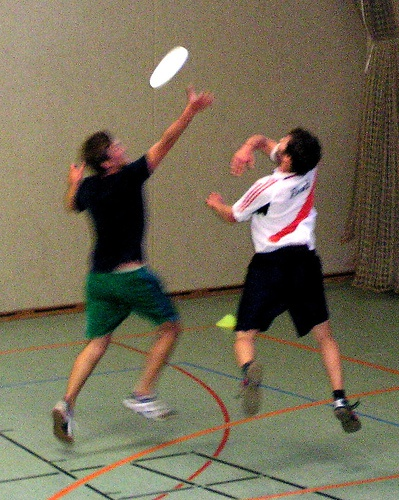Describe the objects in this image and their specific colors. I can see people in tan, black, brown, gray, and maroon tones, people in tan, black, lavender, brown, and gray tones, and frisbee in tan, white, darkgray, and gray tones in this image. 